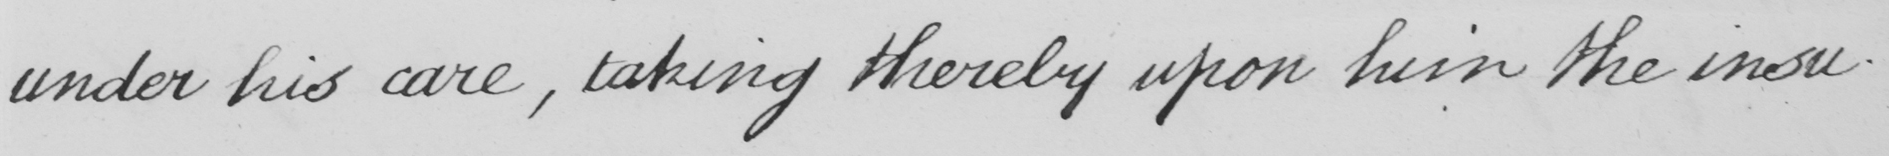Please transcribe the handwritten text in this image. under his care , taking thereby upon him the insu- 